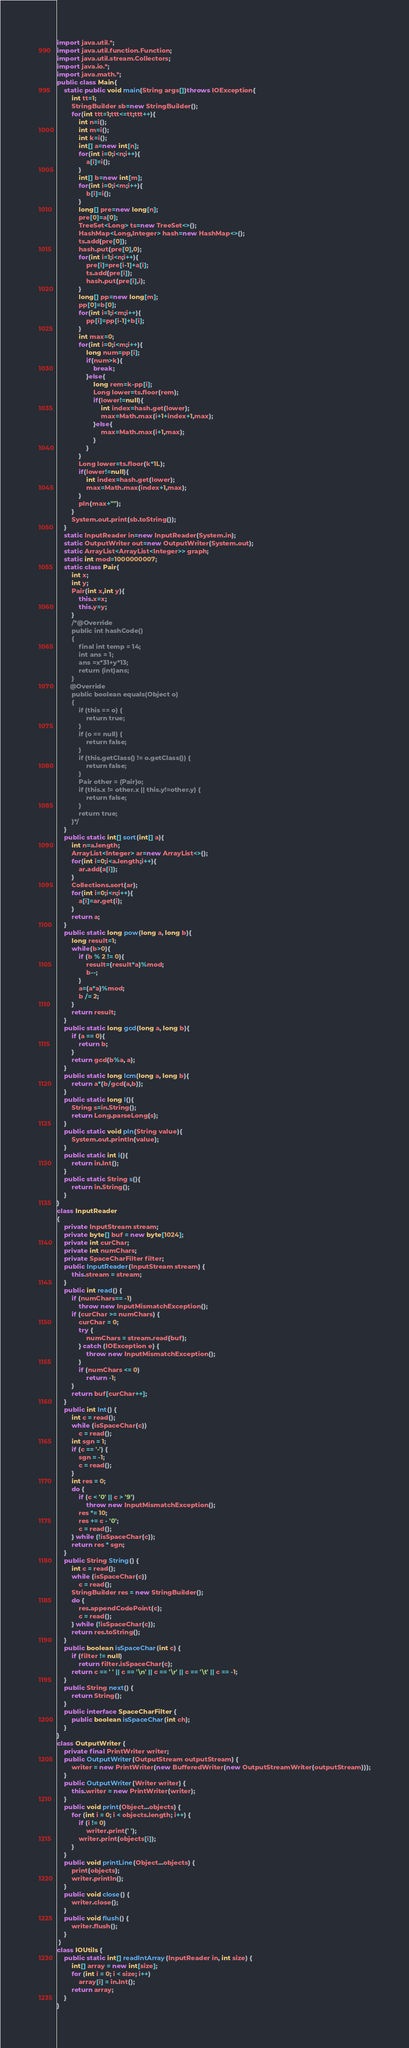<code> <loc_0><loc_0><loc_500><loc_500><_Java_>import java.util.*;		
import java.util.function.Function;
import java.util.stream.Collectors;
import java.io.*;
import java.math.*;
public class Main{
	static public void main(String args[])throws IOException{
		int tt=1;
		StringBuilder sb=new StringBuilder();
		for(int ttt=1;ttt<=tt;ttt++){
			int n=i();
			int m=i();
			int k=i();
			int[] a=new int[n];
			for(int i=0;i<n;i++){
				a[i]=i();
			}
			int[] b=new int[m];
			for(int i=0;i<m;i++){
				b[i]=i();
			}
			long[] pre=new long[n];
			pre[0]=a[0];
			TreeSet<Long> ts=new TreeSet<>();
			HashMap<Long,Integer> hash=new HashMap<>();
			ts.add(pre[0]);
			hash.put(pre[0],0);
			for(int i=1;i<n;i++){
				pre[i]=pre[i-1]+a[i];
				ts.add(pre[i]);
				hash.put(pre[i],i);
			}
			long[] pp=new long[m];
			pp[0]=b[0];
			for(int i=1;i<m;i++){
				pp[i]=pp[i-1]+b[i];
			}
			int max=0;
			for(int i=0;i<m;i++){
				long num=pp[i];
				if(num>k){
					break;
				}else{
					long rem=k-pp[i];
					Long lower=ts.floor(rem);
					if(lower!=null){
						int index=hash.get(lower);
						max=Math.max(i+1+index+1,max);
					}else{
						max=Math.max(i+1,max);
					}
				}
			}
			Long lower=ts.floor(k*1L);
			if(lower!=null){
				int index=hash.get(lower);
				max=Math.max(index+1,max);
			}
			pln(max+"");
		}
		System.out.print(sb.toString());
	}
	static InputReader in=new InputReader(System.in);
	static OutputWriter out=new OutputWriter(System.out);
	static ArrayList<ArrayList<Integer>> graph;
	static int mod=1000000007;
	static class Pair{
		int x;
		int y;
		Pair(int x,int y){
			this.x=x;
			this.y=y;
		}
		/*@Override
		public int hashCode() 
		{ 
			final int temp = 14; 
			int ans = 1; 
			ans =x*31+y*13; 
			return (int)ans;
		}
       @Override
        public boolean equals(Object o) 
        { 
            if (this == o) { 
                return true; 
            } 
            if (o == null) { 
                return false; 
            } 
            if (this.getClass() != o.getClass()) { 
                return false; 
            } 
            Pair other = (Pair)o; 
            if (this.x != other.x || this.y!=other.y) { 
                return false; 
            } 
            return true; 
        }*/
	}
	public static int[] sort(int[] a){
		int n=a.length;
		ArrayList<Integer> ar=new ArrayList<>();
		for(int i=0;i<a.length;i++){
			ar.add(a[i]);
		}
		Collections.sort(ar);
		for(int i=0;i<n;i++){
			a[i]=ar.get(i);
		}
		return a;
	}
	public static long pow(long a, long b){
        long result=1;
        while(b>0){
            if (b % 2 != 0){
                result=(result*a)%mod;
                b--;
            } 
            a=(a*a)%mod;
            b /= 2;
        }   
        return result;
    }
	public static long gcd(long a, long b){
        if (a == 0){
            return b;
		}
        return gcd(b%a, a);
    }
	public static long lcm(long a, long b){
		return a*(b/gcd(a,b));
	}
	public static long l(){
		String s=in.String();
		return Long.parseLong(s);
	}
	public static void pln(String value){
		System.out.println(value);
	}
	public static int i(){
		return in.Int();
	}
	public static String s(){
		return in.String();
	}
}
class InputReader 
{
	private InputStream stream;
	private byte[] buf = new byte[1024];
	private int curChar;
	private int numChars;
	private SpaceCharFilter filter;
	public InputReader(InputStream stream) {
		this.stream = stream;
	}
	public int read() {
		if (numChars== -1)
			throw new InputMismatchException();
		if (curChar >= numChars) {
			curChar = 0;
			try {
				numChars = stream.read(buf);
			} catch (IOException e) {
				throw new InputMismatchException();
			}
			if (numChars <= 0)
				return -1;
		}
		return buf[curChar++];
	}
	public int Int() {
		int c = read();
		while (isSpaceChar(c))
			c = read();
		int sgn = 1;
		if (c == '-') {
			sgn = -1;
			c = read();
		}
		int res = 0;
		do {
			if (c < '0' || c > '9')
				throw new InputMismatchException();
			res *= 10;
			res += c - '0';
			c = read();
		} while (!isSpaceChar(c));
		return res * sgn;
	}
	public String String() {
		int c = read();
		while (isSpaceChar(c))
			c = read();
		StringBuilder res = new StringBuilder();
		do {
			res.appendCodePoint(c);
			c = read();
		} while (!isSpaceChar(c));
		return res.toString();
	} 
	public boolean isSpaceChar(int c) {
		if (filter != null)
			return filter.isSpaceChar(c);
		return c == ' ' || c == '\n' || c == '\r' || c == '\t' || c == -1;
	} 
	public String next() {
		return String();
	} 
	public interface SpaceCharFilter {
		public boolean isSpaceChar(int ch);
	}
}
class OutputWriter {
	private final PrintWriter writer;
	public OutputWriter(OutputStream outputStream) {
		writer = new PrintWriter(new BufferedWriter(new OutputStreamWriter(outputStream)));
	}
	public OutputWriter(Writer writer) {
		this.writer = new PrintWriter(writer);
	}
	public void print(Object...objects) {
		for (int i = 0; i < objects.length; i++) {
			if (i != 0)
				writer.print(' ');
			writer.print(objects[i]);
		}
	}
	public void printLine(Object...objects) {
		print(objects);
		writer.println();
	}
	public void close() {
		writer.close();
	}
	public void flush() {
		writer.flush();
	}
 }
class IOUtils {
	public static int[] readIntArray(InputReader in, int size) {
		int[] array = new int[size];
		for (int i = 0; i < size; i++)
			array[i] = in.Int();
		return array;
	}
} </code> 